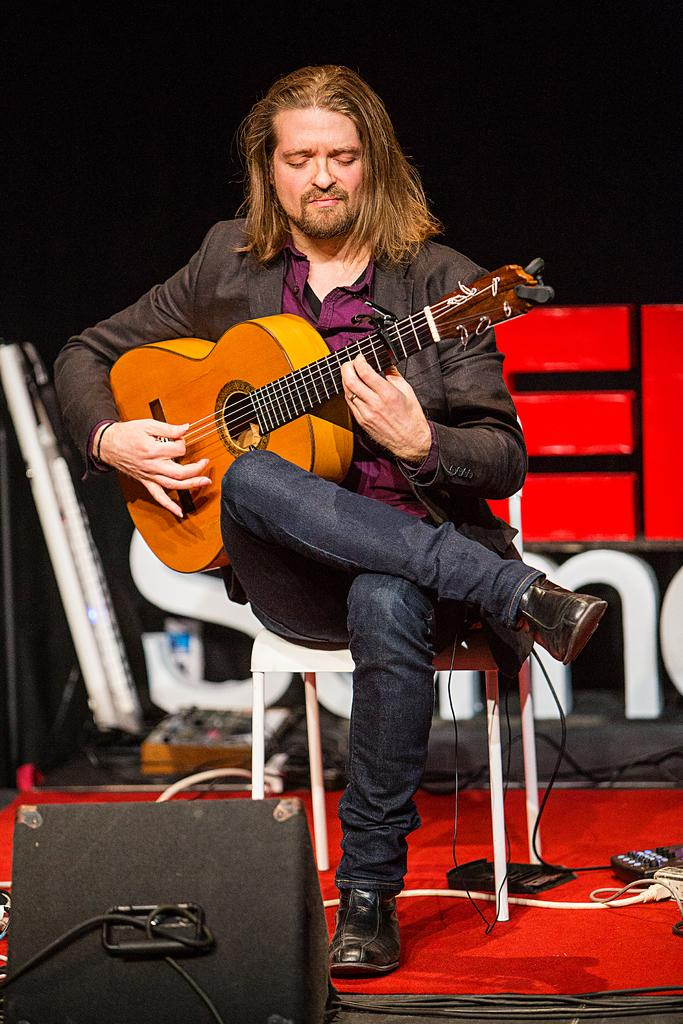What is the main subject of the image? The main subject of the image is a man. What is the man doing in the image? The man is playing a guitar in the image. What is the man's position in the image? The man is seated on a chair in the image. What type of cast can be seen on the man's arm in the image? There is no cast visible on the man's arm in the image. What type of structure is present behind the man in the image? There is no specific structure mentioned in the provided facts, so it cannot be determined from the image. 